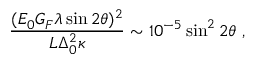<formula> <loc_0><loc_0><loc_500><loc_500>\frac { ( E _ { 0 } G _ { F } \lambda \sin 2 \theta ) ^ { 2 } } { L \Delta _ { 0 } ^ { 2 } \kappa } \sim 1 0 ^ { - 5 } \sin ^ { 2 } 2 \theta \ ,</formula> 